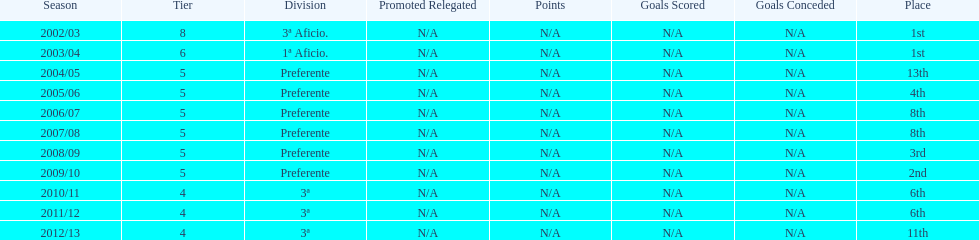Which division placed more than aficio 1a and 3a? Preferente. 